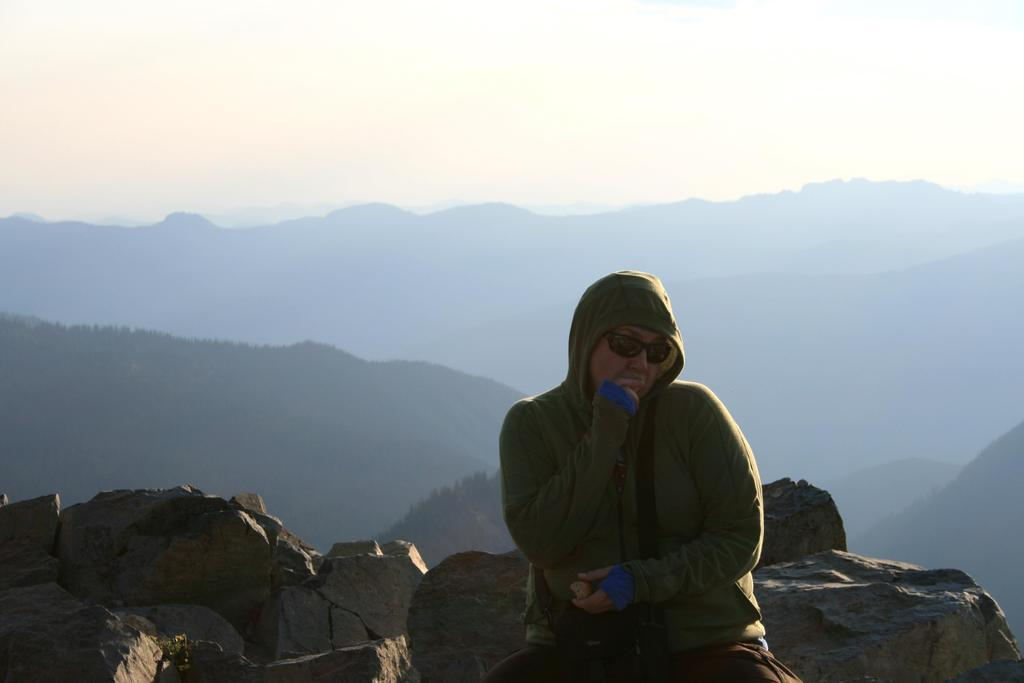What is the person in the image doing? The person is sitting in the image. What is the person wearing on their upper body? The person is wearing a green hoodie. What type of eyewear is the person wearing? The person is wearing goggles. What can be seen in the background of the image? There are trees and mountains in the background of the image. What is visible at the top of the image? The sky is visible at the top of the image. What type of breakfast is the person eating in the image? There is no breakfast present in the image; the person is wearing a green hoodie and goggles while sitting in front of a background with trees, mountains, and the sky. 